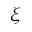<formula> <loc_0><loc_0><loc_500><loc_500>\xi</formula> 